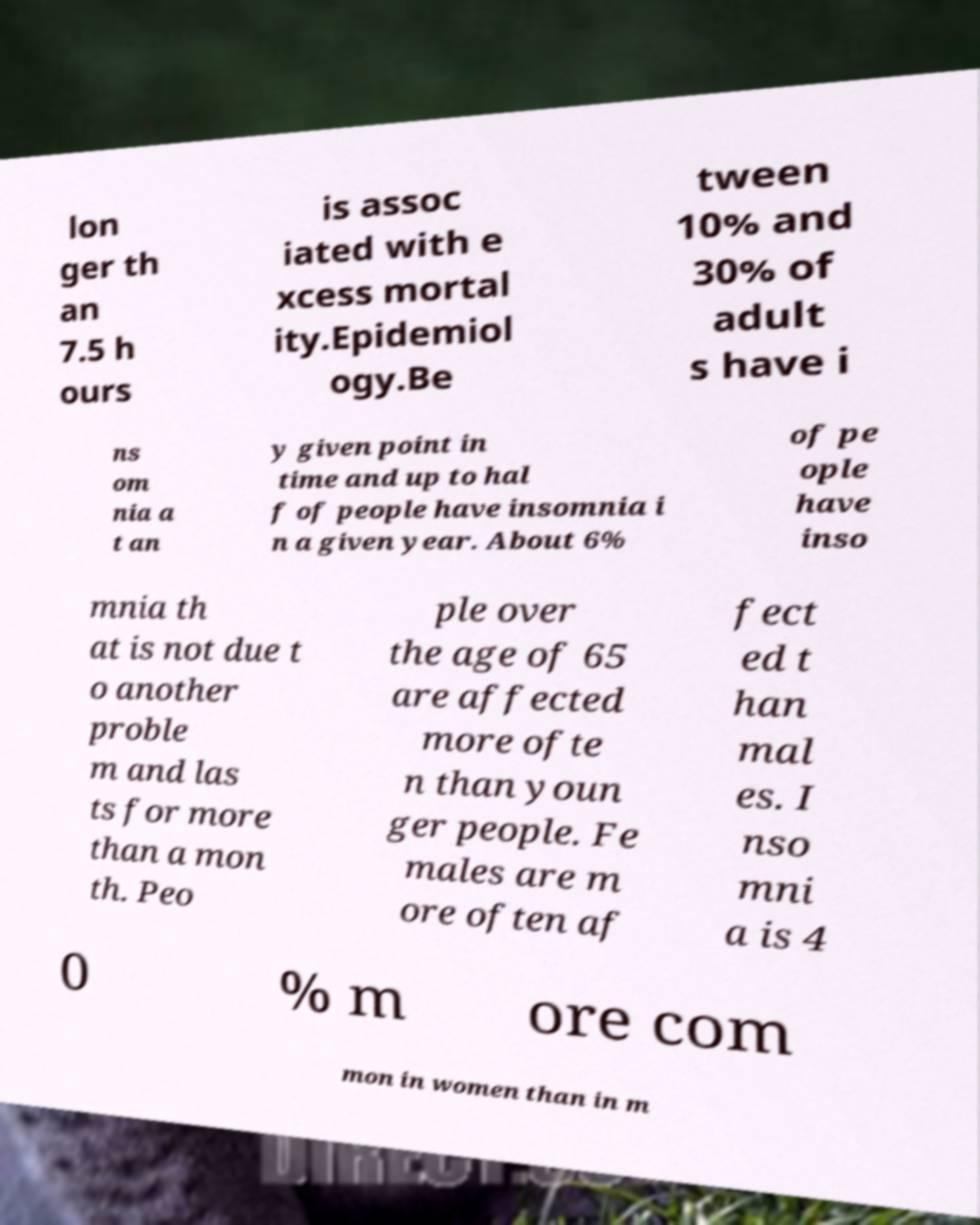I need the written content from this picture converted into text. Can you do that? lon ger th an 7.5 h ours is assoc iated with e xcess mortal ity.Epidemiol ogy.Be tween 10% and 30% of adult s have i ns om nia a t an y given point in time and up to hal f of people have insomnia i n a given year. About 6% of pe ople have inso mnia th at is not due t o another proble m and las ts for more than a mon th. Peo ple over the age of 65 are affected more ofte n than youn ger people. Fe males are m ore often af fect ed t han mal es. I nso mni a is 4 0 % m ore com mon in women than in m 